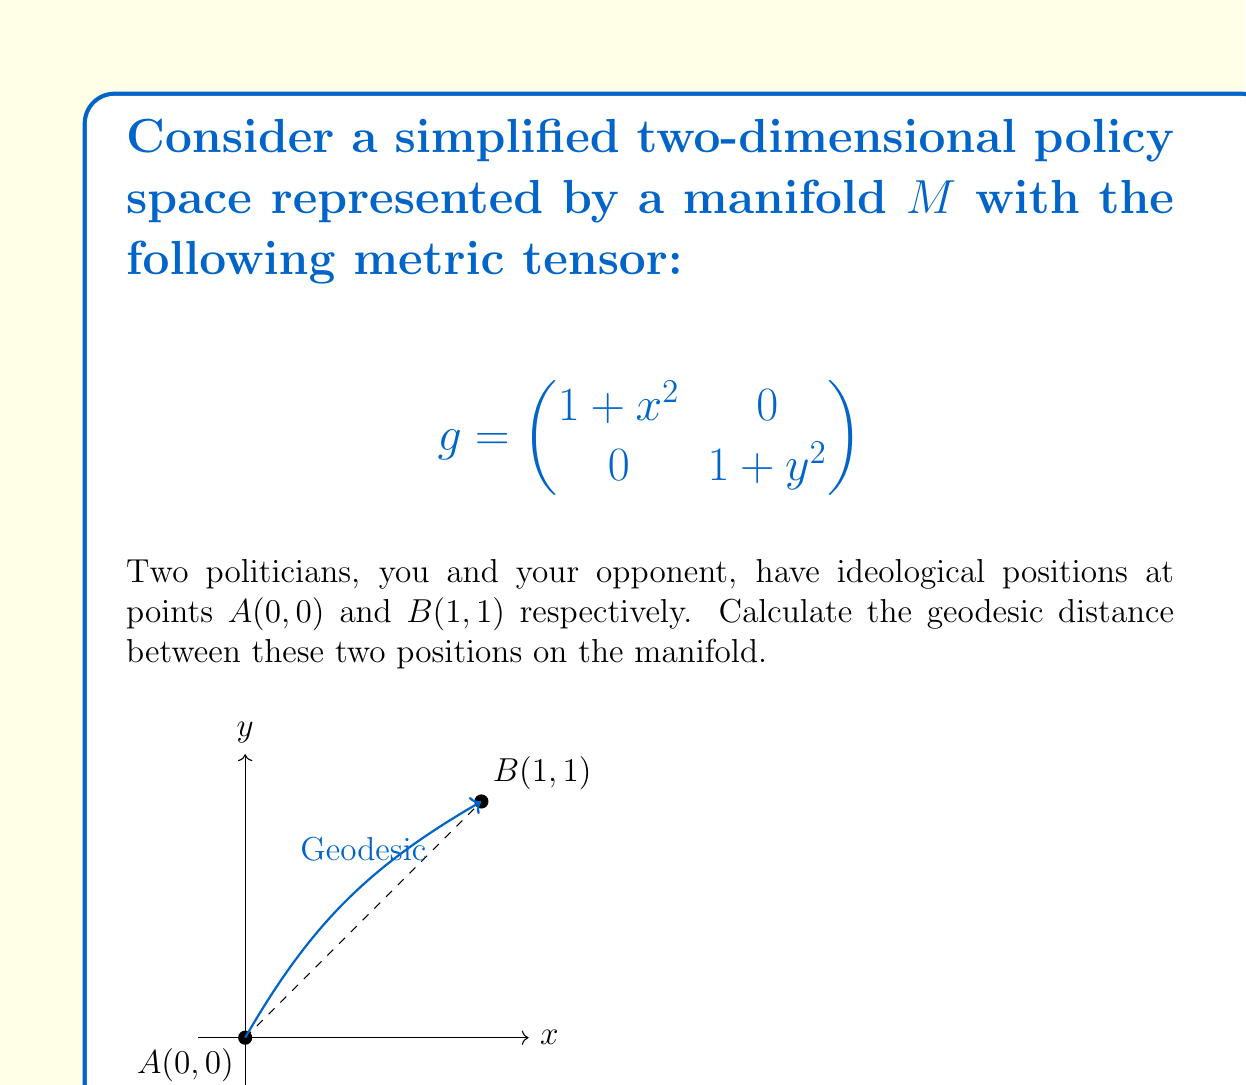Give your solution to this math problem. To solve this problem, we'll follow these steps:

1) The geodesic distance is given by the integral:

   $$d = \int_0^1 \sqrt{g_{ij} \frac{dx^i}{dt} \frac{dx^j}{dt}} dt$$

2) We need to parameterize the path. Let's use $t \in [0,1]$ such that:
   
   $x(t) = t$ and $y(t) = t$

3) Then, $\frac{dx}{dt} = 1$ and $\frac{dy}{dt} = 1$

4) Substituting into the integral:

   $$d = \int_0^1 \sqrt{(1+t^2)(1)^2 + (1+t^2)(1)^2} dt$$

5) Simplifying:

   $$d = \int_0^1 \sqrt{2(1+t^2)} dt$$

6) This can be rewritten as:

   $$d = \sqrt{2} \int_0^1 \sqrt{1+t^2} dt$$

7) This integral can be solved using the substitution $t = \sinh u$:

   $$d = \sqrt{2} [\sinh u \cosh u + u]_0^{\sinh^{-1}(1)}$$

8) Evaluating the limits:

   $$d = \sqrt{2} (\sinh(\sinh^{-1}(1)) \cosh(\sinh^{-1}(1)) + \sinh^{-1}(1))$$

9) Simplifying:

   $$d = \sqrt{2} (1 \cdot \sqrt{2} + \ln(1 + \sqrt{2}))$$

10) Final result:

    $$d = 2 + \sqrt{2} \ln(1 + \sqrt{2})$$
Answer: $2 + \sqrt{2} \ln(1 + \sqrt{2})$ 